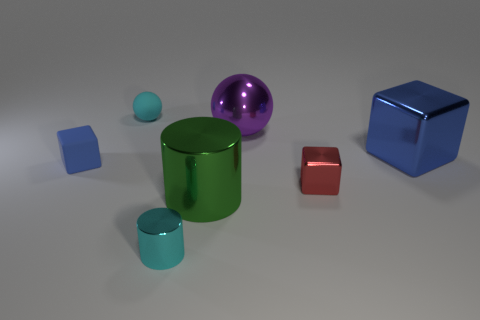Subtract all red cylinders. How many blue blocks are left? 2 Subtract all red metallic cubes. How many cubes are left? 2 Add 2 gray rubber things. How many objects exist? 9 Subtract all cylinders. How many objects are left? 5 Subtract all cyan cubes. Subtract all green spheres. How many cubes are left? 3 Subtract all small red metal things. Subtract all shiny things. How many objects are left? 1 Add 6 tiny cylinders. How many tiny cylinders are left? 7 Add 6 small rubber blocks. How many small rubber blocks exist? 7 Subtract 0 purple cylinders. How many objects are left? 7 